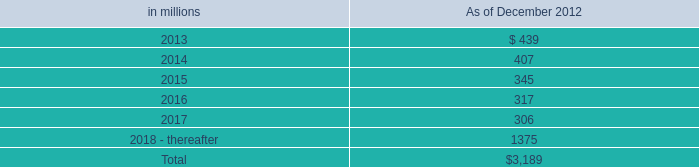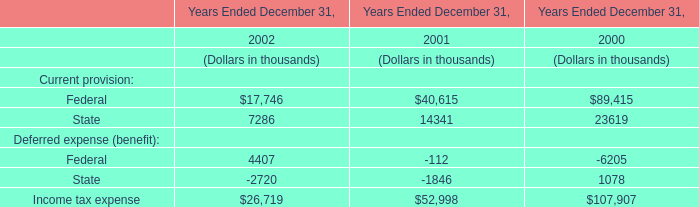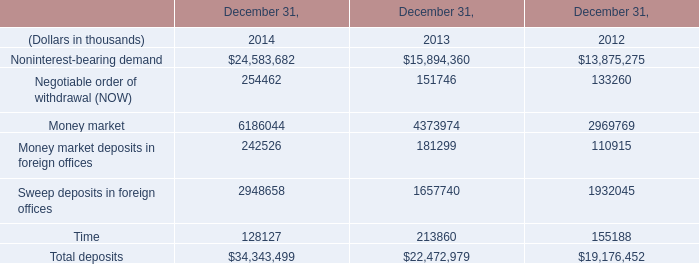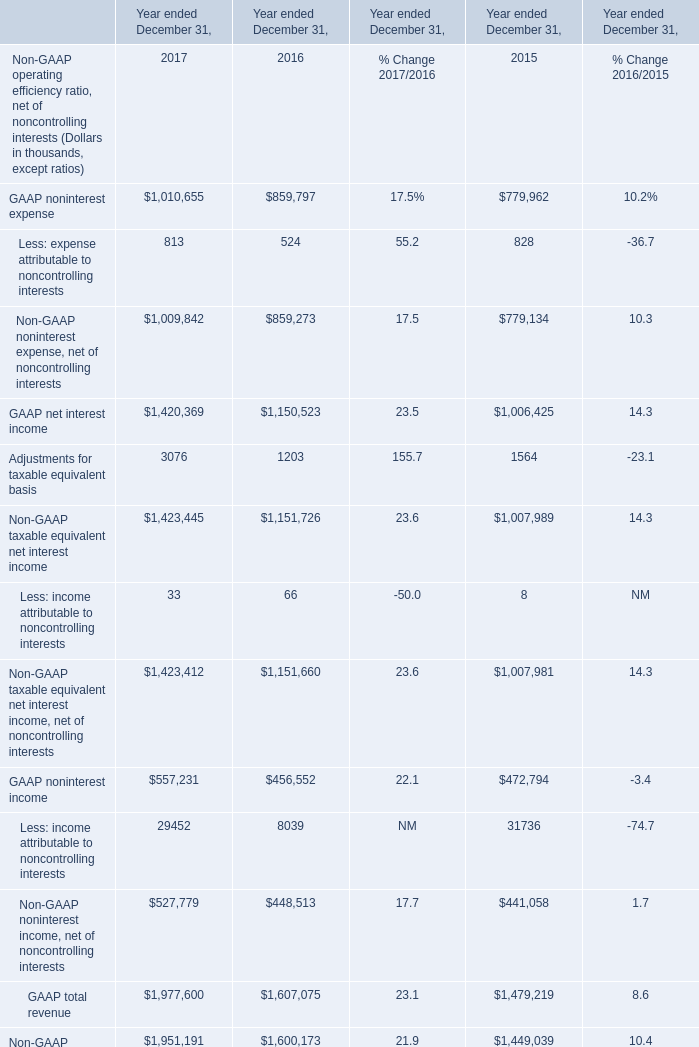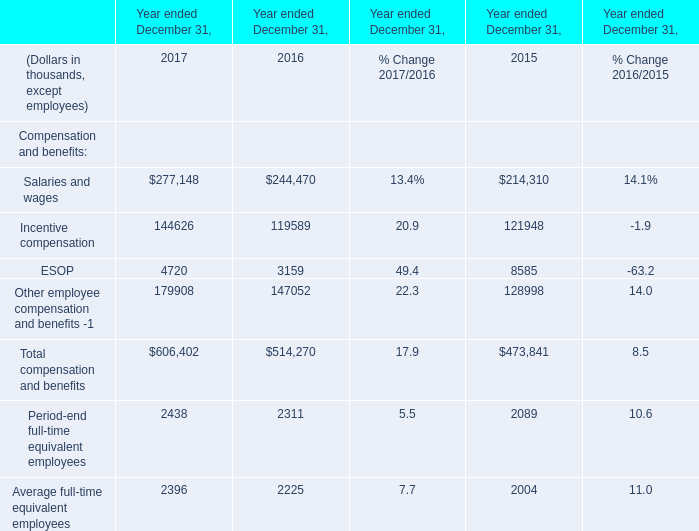What is the total value of Salaries and wages,Incentive compensation, ESOP and Other employee compensation and benefits -1 in 2016？ (in thousand) 
Computations: (((244470 + 119589) + 3159) + 147052)
Answer: 514270.0. 